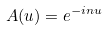<formula> <loc_0><loc_0><loc_500><loc_500>A ( u ) = e ^ { - i n u }</formula> 